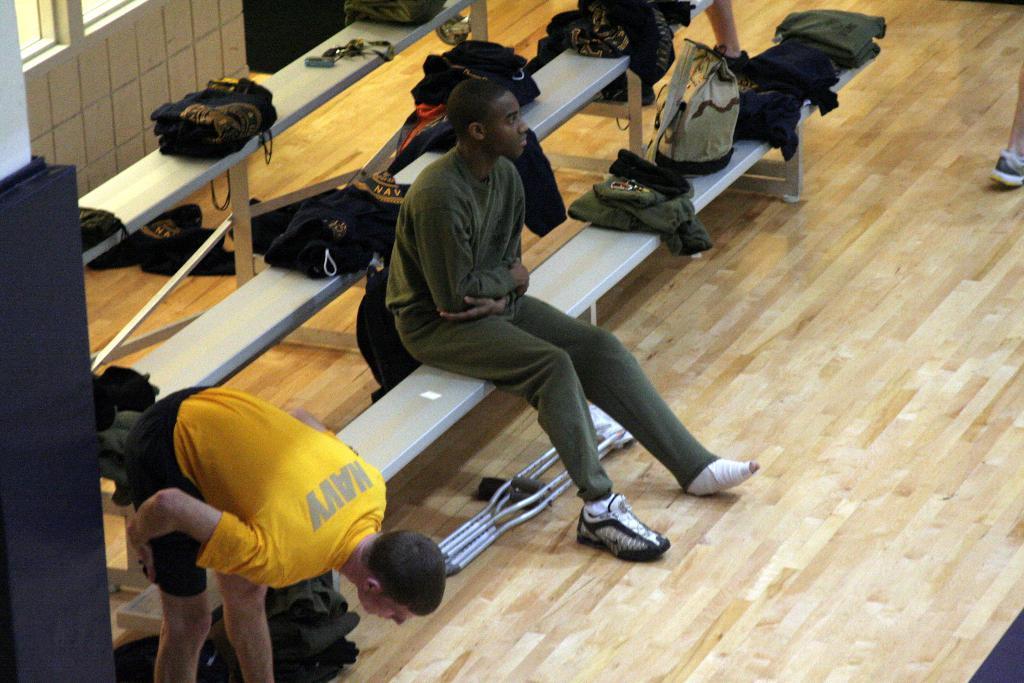How would you summarize this image in a sentence or two? This is an inside view. On the left side there are few benches on which I can see many bags and one person is sitting on the bench facing towards the right side. Another person is bending. At the bottom, I can see the floor. On the right side I can see a person's foot. In the top left there is a window to the wall. 